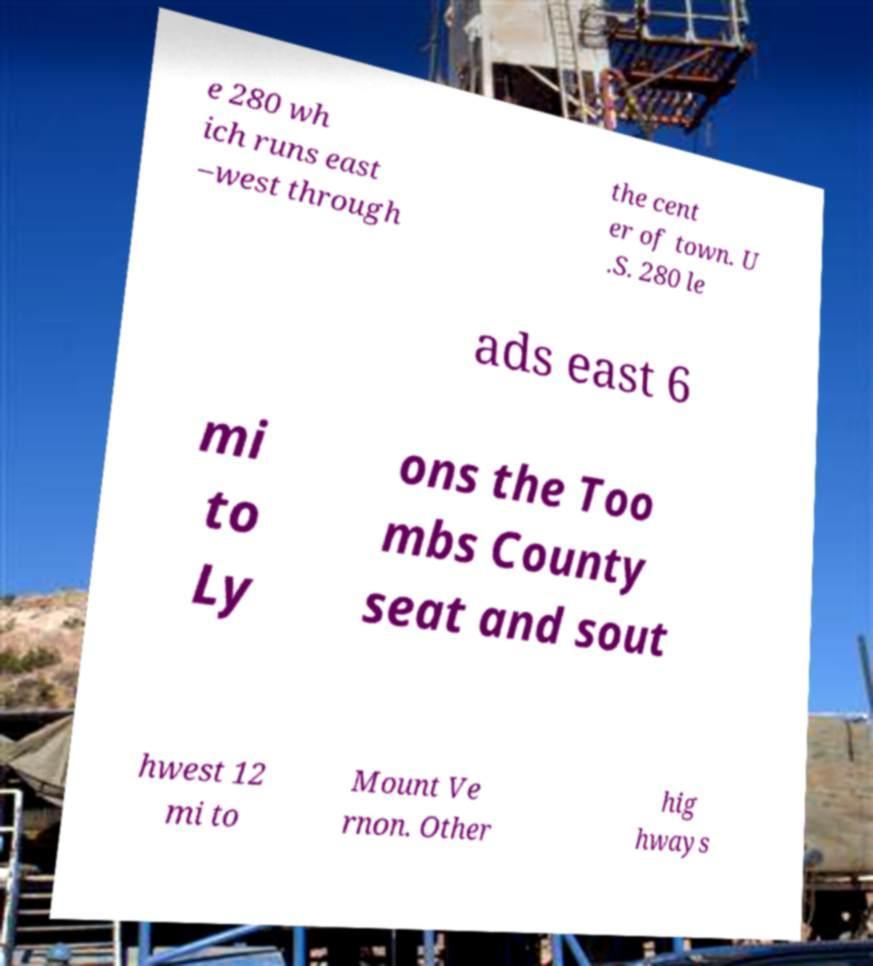What messages or text are displayed in this image? I need them in a readable, typed format. e 280 wh ich runs east –west through the cent er of town. U .S. 280 le ads east 6 mi to Ly ons the Too mbs County seat and sout hwest 12 mi to Mount Ve rnon. Other hig hways 